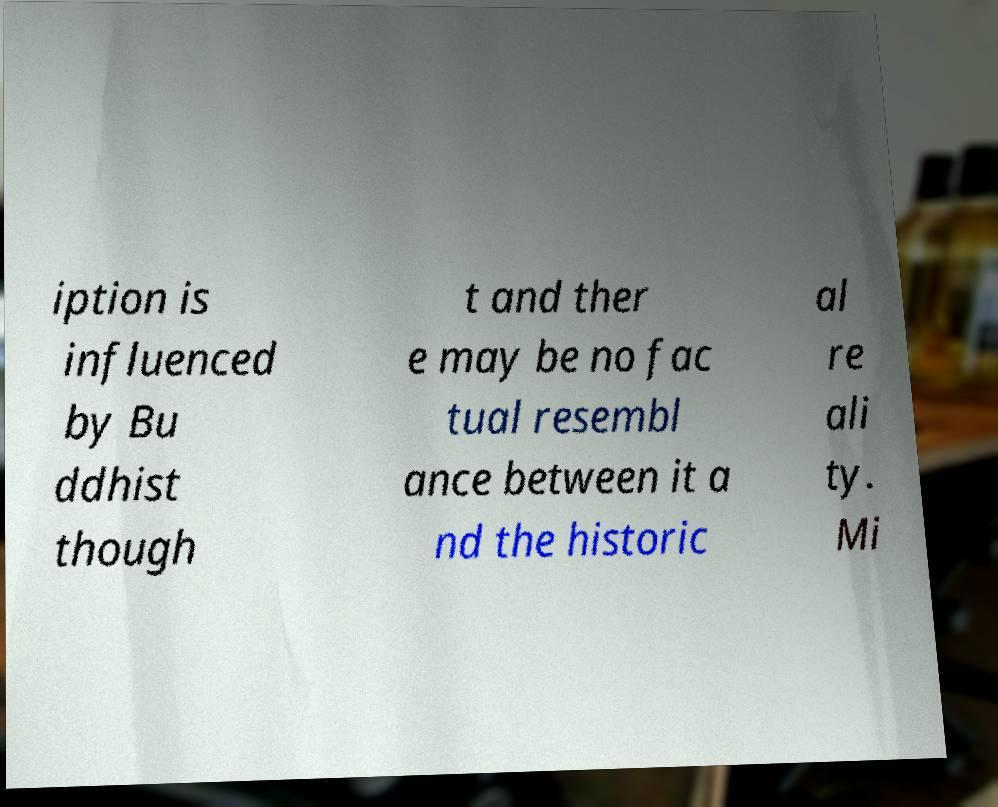Please read and relay the text visible in this image. What does it say? iption is influenced by Bu ddhist though t and ther e may be no fac tual resembl ance between it a nd the historic al re ali ty. Mi 